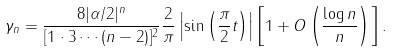Convert formula to latex. <formula><loc_0><loc_0><loc_500><loc_500>\gamma _ { n } = \frac { 8 | \alpha / 2 | ^ { n } } { [ 1 \cdot 3 \cdots ( n - 2 ) ] ^ { 2 } } \frac { 2 } { \pi } \left | \sin \left ( \frac { \pi } { 2 } t \right ) \right | \left [ 1 + O \left ( \frac { \log n } { n } \right ) \right ] .</formula> 